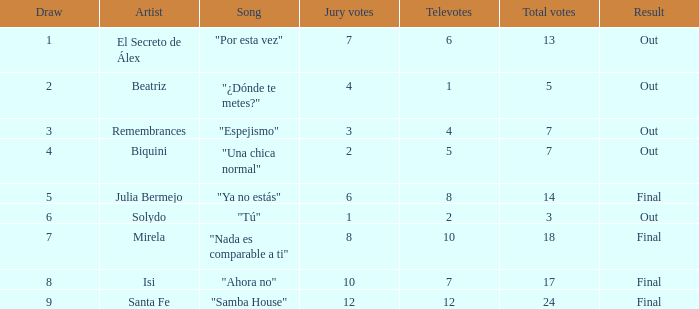State the total of songs associated with solydo. 1.0. 